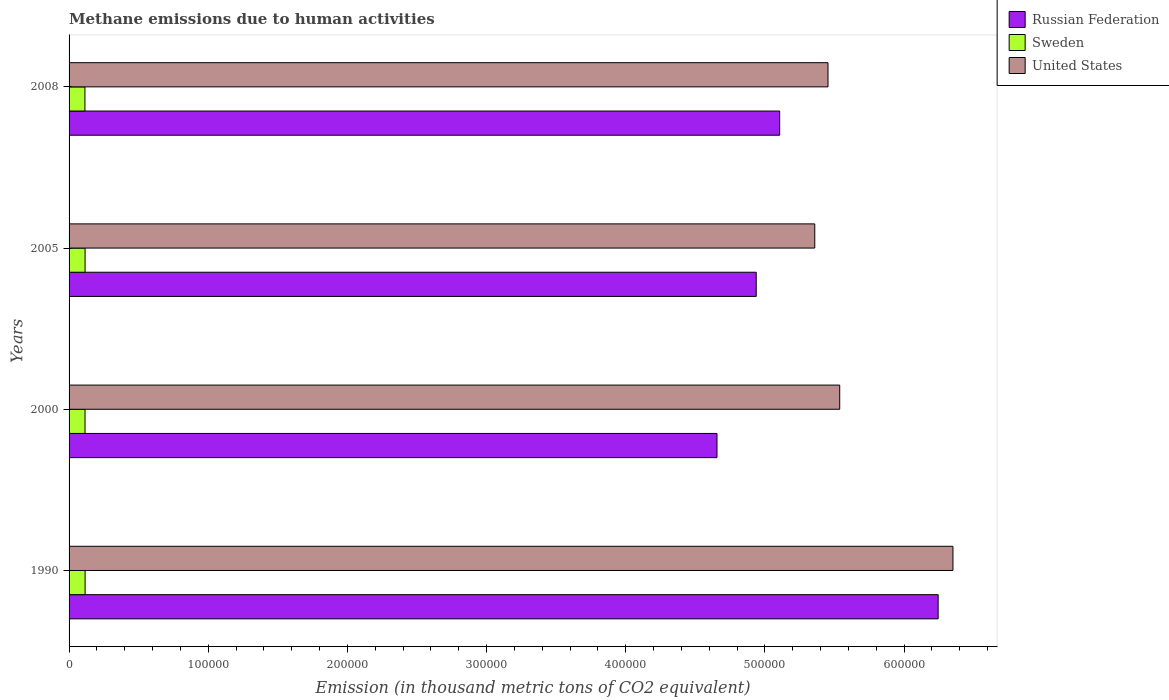Are the number of bars per tick equal to the number of legend labels?
Give a very brief answer. Yes. Are the number of bars on each tick of the Y-axis equal?
Provide a short and direct response. Yes. How many bars are there on the 4th tick from the top?
Your answer should be very brief. 3. How many bars are there on the 3rd tick from the bottom?
Provide a succinct answer. 3. In how many cases, is the number of bars for a given year not equal to the number of legend labels?
Ensure brevity in your answer.  0. What is the amount of methane emitted in Sweden in 1990?
Offer a terse response. 1.15e+04. Across all years, what is the maximum amount of methane emitted in Sweden?
Offer a terse response. 1.15e+04. Across all years, what is the minimum amount of methane emitted in Sweden?
Offer a very short reply. 1.14e+04. What is the total amount of methane emitted in United States in the graph?
Make the answer very short. 2.27e+06. What is the difference between the amount of methane emitted in United States in 1990 and that in 2000?
Provide a succinct answer. 8.14e+04. What is the difference between the amount of methane emitted in Russian Federation in 1990 and the amount of methane emitted in Sweden in 2000?
Ensure brevity in your answer.  6.13e+05. What is the average amount of methane emitted in United States per year?
Give a very brief answer. 5.67e+05. In the year 1990, what is the difference between the amount of methane emitted in United States and amount of methane emitted in Sweden?
Offer a very short reply. 6.24e+05. What is the ratio of the amount of methane emitted in Sweden in 1990 to that in 2000?
Make the answer very short. 1. Is the amount of methane emitted in Russian Federation in 2000 less than that in 2005?
Your answer should be very brief. Yes. Is the difference between the amount of methane emitted in United States in 1990 and 2005 greater than the difference between the amount of methane emitted in Sweden in 1990 and 2005?
Offer a terse response. Yes. What is the difference between the highest and the second highest amount of methane emitted in United States?
Make the answer very short. 8.14e+04. What is the difference between the highest and the lowest amount of methane emitted in Russian Federation?
Your answer should be very brief. 1.59e+05. What does the 2nd bar from the top in 1990 represents?
Provide a succinct answer. Sweden. Is it the case that in every year, the sum of the amount of methane emitted in Russian Federation and amount of methane emitted in Sweden is greater than the amount of methane emitted in United States?
Provide a short and direct response. No. What is the difference between two consecutive major ticks on the X-axis?
Offer a very short reply. 1.00e+05. Are the values on the major ticks of X-axis written in scientific E-notation?
Your answer should be compact. No. Does the graph contain any zero values?
Your response must be concise. No. Where does the legend appear in the graph?
Your response must be concise. Top right. How many legend labels are there?
Keep it short and to the point. 3. How are the legend labels stacked?
Keep it short and to the point. Vertical. What is the title of the graph?
Provide a succinct answer. Methane emissions due to human activities. What is the label or title of the X-axis?
Offer a terse response. Emission (in thousand metric tons of CO2 equivalent). What is the Emission (in thousand metric tons of CO2 equivalent) of Russian Federation in 1990?
Make the answer very short. 6.24e+05. What is the Emission (in thousand metric tons of CO2 equivalent) of Sweden in 1990?
Provide a short and direct response. 1.15e+04. What is the Emission (in thousand metric tons of CO2 equivalent) of United States in 1990?
Your answer should be compact. 6.35e+05. What is the Emission (in thousand metric tons of CO2 equivalent) in Russian Federation in 2000?
Your answer should be very brief. 4.66e+05. What is the Emission (in thousand metric tons of CO2 equivalent) of Sweden in 2000?
Your answer should be very brief. 1.15e+04. What is the Emission (in thousand metric tons of CO2 equivalent) of United States in 2000?
Keep it short and to the point. 5.54e+05. What is the Emission (in thousand metric tons of CO2 equivalent) of Russian Federation in 2005?
Provide a short and direct response. 4.94e+05. What is the Emission (in thousand metric tons of CO2 equivalent) in Sweden in 2005?
Offer a terse response. 1.15e+04. What is the Emission (in thousand metric tons of CO2 equivalent) of United States in 2005?
Make the answer very short. 5.36e+05. What is the Emission (in thousand metric tons of CO2 equivalent) in Russian Federation in 2008?
Offer a terse response. 5.11e+05. What is the Emission (in thousand metric tons of CO2 equivalent) in Sweden in 2008?
Ensure brevity in your answer.  1.14e+04. What is the Emission (in thousand metric tons of CO2 equivalent) in United States in 2008?
Give a very brief answer. 5.45e+05. Across all years, what is the maximum Emission (in thousand metric tons of CO2 equivalent) of Russian Federation?
Make the answer very short. 6.24e+05. Across all years, what is the maximum Emission (in thousand metric tons of CO2 equivalent) in Sweden?
Your response must be concise. 1.15e+04. Across all years, what is the maximum Emission (in thousand metric tons of CO2 equivalent) in United States?
Offer a terse response. 6.35e+05. Across all years, what is the minimum Emission (in thousand metric tons of CO2 equivalent) of Russian Federation?
Give a very brief answer. 4.66e+05. Across all years, what is the minimum Emission (in thousand metric tons of CO2 equivalent) in Sweden?
Ensure brevity in your answer.  1.14e+04. Across all years, what is the minimum Emission (in thousand metric tons of CO2 equivalent) in United States?
Your answer should be compact. 5.36e+05. What is the total Emission (in thousand metric tons of CO2 equivalent) of Russian Federation in the graph?
Your response must be concise. 2.09e+06. What is the total Emission (in thousand metric tons of CO2 equivalent) of Sweden in the graph?
Offer a very short reply. 4.59e+04. What is the total Emission (in thousand metric tons of CO2 equivalent) in United States in the graph?
Offer a very short reply. 2.27e+06. What is the difference between the Emission (in thousand metric tons of CO2 equivalent) of Russian Federation in 1990 and that in 2000?
Offer a terse response. 1.59e+05. What is the difference between the Emission (in thousand metric tons of CO2 equivalent) in United States in 1990 and that in 2000?
Provide a succinct answer. 8.14e+04. What is the difference between the Emission (in thousand metric tons of CO2 equivalent) in Russian Federation in 1990 and that in 2005?
Your response must be concise. 1.31e+05. What is the difference between the Emission (in thousand metric tons of CO2 equivalent) in United States in 1990 and that in 2005?
Provide a succinct answer. 9.93e+04. What is the difference between the Emission (in thousand metric tons of CO2 equivalent) of Russian Federation in 1990 and that in 2008?
Provide a short and direct response. 1.14e+05. What is the difference between the Emission (in thousand metric tons of CO2 equivalent) of Sweden in 1990 and that in 2008?
Make the answer very short. 129.2. What is the difference between the Emission (in thousand metric tons of CO2 equivalent) of United States in 1990 and that in 2008?
Offer a very short reply. 8.98e+04. What is the difference between the Emission (in thousand metric tons of CO2 equivalent) in Russian Federation in 2000 and that in 2005?
Your response must be concise. -2.82e+04. What is the difference between the Emission (in thousand metric tons of CO2 equivalent) in Sweden in 2000 and that in 2005?
Offer a very short reply. -34.6. What is the difference between the Emission (in thousand metric tons of CO2 equivalent) of United States in 2000 and that in 2005?
Provide a succinct answer. 1.79e+04. What is the difference between the Emission (in thousand metric tons of CO2 equivalent) in Russian Federation in 2000 and that in 2008?
Provide a succinct answer. -4.51e+04. What is the difference between the Emission (in thousand metric tons of CO2 equivalent) of Sweden in 2000 and that in 2008?
Provide a succinct answer. 76.2. What is the difference between the Emission (in thousand metric tons of CO2 equivalent) of United States in 2000 and that in 2008?
Ensure brevity in your answer.  8414.7. What is the difference between the Emission (in thousand metric tons of CO2 equivalent) of Russian Federation in 2005 and that in 2008?
Offer a terse response. -1.69e+04. What is the difference between the Emission (in thousand metric tons of CO2 equivalent) in Sweden in 2005 and that in 2008?
Keep it short and to the point. 110.8. What is the difference between the Emission (in thousand metric tons of CO2 equivalent) in United States in 2005 and that in 2008?
Your response must be concise. -9510.3. What is the difference between the Emission (in thousand metric tons of CO2 equivalent) of Russian Federation in 1990 and the Emission (in thousand metric tons of CO2 equivalent) of Sweden in 2000?
Your answer should be compact. 6.13e+05. What is the difference between the Emission (in thousand metric tons of CO2 equivalent) in Russian Federation in 1990 and the Emission (in thousand metric tons of CO2 equivalent) in United States in 2000?
Your answer should be very brief. 7.07e+04. What is the difference between the Emission (in thousand metric tons of CO2 equivalent) in Sweden in 1990 and the Emission (in thousand metric tons of CO2 equivalent) in United States in 2000?
Offer a terse response. -5.42e+05. What is the difference between the Emission (in thousand metric tons of CO2 equivalent) in Russian Federation in 1990 and the Emission (in thousand metric tons of CO2 equivalent) in Sweden in 2005?
Offer a terse response. 6.13e+05. What is the difference between the Emission (in thousand metric tons of CO2 equivalent) of Russian Federation in 1990 and the Emission (in thousand metric tons of CO2 equivalent) of United States in 2005?
Your answer should be very brief. 8.87e+04. What is the difference between the Emission (in thousand metric tons of CO2 equivalent) in Sweden in 1990 and the Emission (in thousand metric tons of CO2 equivalent) in United States in 2005?
Make the answer very short. -5.24e+05. What is the difference between the Emission (in thousand metric tons of CO2 equivalent) in Russian Federation in 1990 and the Emission (in thousand metric tons of CO2 equivalent) in Sweden in 2008?
Your answer should be compact. 6.13e+05. What is the difference between the Emission (in thousand metric tons of CO2 equivalent) of Russian Federation in 1990 and the Emission (in thousand metric tons of CO2 equivalent) of United States in 2008?
Your response must be concise. 7.92e+04. What is the difference between the Emission (in thousand metric tons of CO2 equivalent) of Sweden in 1990 and the Emission (in thousand metric tons of CO2 equivalent) of United States in 2008?
Give a very brief answer. -5.34e+05. What is the difference between the Emission (in thousand metric tons of CO2 equivalent) of Russian Federation in 2000 and the Emission (in thousand metric tons of CO2 equivalent) of Sweden in 2005?
Your answer should be very brief. 4.54e+05. What is the difference between the Emission (in thousand metric tons of CO2 equivalent) in Russian Federation in 2000 and the Emission (in thousand metric tons of CO2 equivalent) in United States in 2005?
Offer a terse response. -7.03e+04. What is the difference between the Emission (in thousand metric tons of CO2 equivalent) in Sweden in 2000 and the Emission (in thousand metric tons of CO2 equivalent) in United States in 2005?
Make the answer very short. -5.24e+05. What is the difference between the Emission (in thousand metric tons of CO2 equivalent) of Russian Federation in 2000 and the Emission (in thousand metric tons of CO2 equivalent) of Sweden in 2008?
Provide a short and direct response. 4.54e+05. What is the difference between the Emission (in thousand metric tons of CO2 equivalent) in Russian Federation in 2000 and the Emission (in thousand metric tons of CO2 equivalent) in United States in 2008?
Offer a very short reply. -7.98e+04. What is the difference between the Emission (in thousand metric tons of CO2 equivalent) of Sweden in 2000 and the Emission (in thousand metric tons of CO2 equivalent) of United States in 2008?
Your answer should be compact. -5.34e+05. What is the difference between the Emission (in thousand metric tons of CO2 equivalent) in Russian Federation in 2005 and the Emission (in thousand metric tons of CO2 equivalent) in Sweden in 2008?
Make the answer very short. 4.82e+05. What is the difference between the Emission (in thousand metric tons of CO2 equivalent) in Russian Federation in 2005 and the Emission (in thousand metric tons of CO2 equivalent) in United States in 2008?
Make the answer very short. -5.16e+04. What is the difference between the Emission (in thousand metric tons of CO2 equivalent) in Sweden in 2005 and the Emission (in thousand metric tons of CO2 equivalent) in United States in 2008?
Ensure brevity in your answer.  -5.34e+05. What is the average Emission (in thousand metric tons of CO2 equivalent) of Russian Federation per year?
Your response must be concise. 5.24e+05. What is the average Emission (in thousand metric tons of CO2 equivalent) of Sweden per year?
Ensure brevity in your answer.  1.15e+04. What is the average Emission (in thousand metric tons of CO2 equivalent) in United States per year?
Provide a succinct answer. 5.67e+05. In the year 1990, what is the difference between the Emission (in thousand metric tons of CO2 equivalent) in Russian Federation and Emission (in thousand metric tons of CO2 equivalent) in Sweden?
Your answer should be very brief. 6.13e+05. In the year 1990, what is the difference between the Emission (in thousand metric tons of CO2 equivalent) in Russian Federation and Emission (in thousand metric tons of CO2 equivalent) in United States?
Offer a terse response. -1.06e+04. In the year 1990, what is the difference between the Emission (in thousand metric tons of CO2 equivalent) in Sweden and Emission (in thousand metric tons of CO2 equivalent) in United States?
Your answer should be very brief. -6.24e+05. In the year 2000, what is the difference between the Emission (in thousand metric tons of CO2 equivalent) in Russian Federation and Emission (in thousand metric tons of CO2 equivalent) in Sweden?
Provide a succinct answer. 4.54e+05. In the year 2000, what is the difference between the Emission (in thousand metric tons of CO2 equivalent) of Russian Federation and Emission (in thousand metric tons of CO2 equivalent) of United States?
Your answer should be compact. -8.82e+04. In the year 2000, what is the difference between the Emission (in thousand metric tons of CO2 equivalent) in Sweden and Emission (in thousand metric tons of CO2 equivalent) in United States?
Offer a terse response. -5.42e+05. In the year 2005, what is the difference between the Emission (in thousand metric tons of CO2 equivalent) in Russian Federation and Emission (in thousand metric tons of CO2 equivalent) in Sweden?
Offer a very short reply. 4.82e+05. In the year 2005, what is the difference between the Emission (in thousand metric tons of CO2 equivalent) of Russian Federation and Emission (in thousand metric tons of CO2 equivalent) of United States?
Your response must be concise. -4.21e+04. In the year 2005, what is the difference between the Emission (in thousand metric tons of CO2 equivalent) in Sweden and Emission (in thousand metric tons of CO2 equivalent) in United States?
Offer a terse response. -5.24e+05. In the year 2008, what is the difference between the Emission (in thousand metric tons of CO2 equivalent) of Russian Federation and Emission (in thousand metric tons of CO2 equivalent) of Sweden?
Your answer should be compact. 4.99e+05. In the year 2008, what is the difference between the Emission (in thousand metric tons of CO2 equivalent) of Russian Federation and Emission (in thousand metric tons of CO2 equivalent) of United States?
Your answer should be compact. -3.47e+04. In the year 2008, what is the difference between the Emission (in thousand metric tons of CO2 equivalent) in Sweden and Emission (in thousand metric tons of CO2 equivalent) in United States?
Provide a succinct answer. -5.34e+05. What is the ratio of the Emission (in thousand metric tons of CO2 equivalent) in Russian Federation in 1990 to that in 2000?
Ensure brevity in your answer.  1.34. What is the ratio of the Emission (in thousand metric tons of CO2 equivalent) in Sweden in 1990 to that in 2000?
Provide a succinct answer. 1. What is the ratio of the Emission (in thousand metric tons of CO2 equivalent) in United States in 1990 to that in 2000?
Provide a short and direct response. 1.15. What is the ratio of the Emission (in thousand metric tons of CO2 equivalent) in Russian Federation in 1990 to that in 2005?
Keep it short and to the point. 1.26. What is the ratio of the Emission (in thousand metric tons of CO2 equivalent) of United States in 1990 to that in 2005?
Make the answer very short. 1.19. What is the ratio of the Emission (in thousand metric tons of CO2 equivalent) in Russian Federation in 1990 to that in 2008?
Make the answer very short. 1.22. What is the ratio of the Emission (in thousand metric tons of CO2 equivalent) of Sweden in 1990 to that in 2008?
Your answer should be very brief. 1.01. What is the ratio of the Emission (in thousand metric tons of CO2 equivalent) in United States in 1990 to that in 2008?
Your answer should be compact. 1.16. What is the ratio of the Emission (in thousand metric tons of CO2 equivalent) of Russian Federation in 2000 to that in 2005?
Keep it short and to the point. 0.94. What is the ratio of the Emission (in thousand metric tons of CO2 equivalent) in United States in 2000 to that in 2005?
Your answer should be very brief. 1.03. What is the ratio of the Emission (in thousand metric tons of CO2 equivalent) in Russian Federation in 2000 to that in 2008?
Your answer should be very brief. 0.91. What is the ratio of the Emission (in thousand metric tons of CO2 equivalent) in United States in 2000 to that in 2008?
Ensure brevity in your answer.  1.02. What is the ratio of the Emission (in thousand metric tons of CO2 equivalent) in Sweden in 2005 to that in 2008?
Ensure brevity in your answer.  1.01. What is the ratio of the Emission (in thousand metric tons of CO2 equivalent) of United States in 2005 to that in 2008?
Your answer should be very brief. 0.98. What is the difference between the highest and the second highest Emission (in thousand metric tons of CO2 equivalent) of Russian Federation?
Provide a short and direct response. 1.14e+05. What is the difference between the highest and the second highest Emission (in thousand metric tons of CO2 equivalent) in Sweden?
Your answer should be very brief. 18.4. What is the difference between the highest and the second highest Emission (in thousand metric tons of CO2 equivalent) in United States?
Keep it short and to the point. 8.14e+04. What is the difference between the highest and the lowest Emission (in thousand metric tons of CO2 equivalent) in Russian Federation?
Ensure brevity in your answer.  1.59e+05. What is the difference between the highest and the lowest Emission (in thousand metric tons of CO2 equivalent) in Sweden?
Ensure brevity in your answer.  129.2. What is the difference between the highest and the lowest Emission (in thousand metric tons of CO2 equivalent) of United States?
Offer a very short reply. 9.93e+04. 